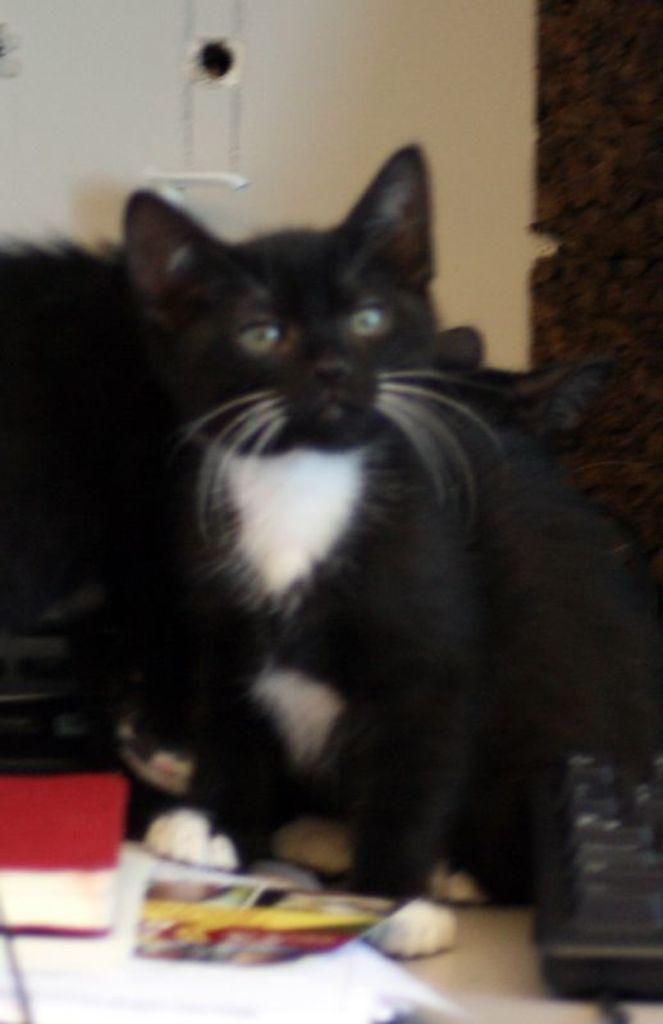What type of animal is in the image? There is a black cat in the image. Where is the cat positioned in relation to the camera? The cat is sitting in front. What is the cat doing in the image? The cat is looking at the camera. What can be seen behind the cat in the image? There is a white wall in the background of the image. What type of art is displayed on the wall behind the cat? There is no art displayed on the wall behind the cat; it is a plain white wall. What type of food is the cat holding in its paws? The cat is not holding any food in its paws; it is simply sitting and looking at the camera. 